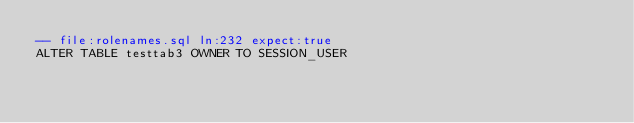Convert code to text. <code><loc_0><loc_0><loc_500><loc_500><_SQL_>-- file:rolenames.sql ln:232 expect:true
ALTER TABLE testtab3 OWNER TO SESSION_USER
</code> 